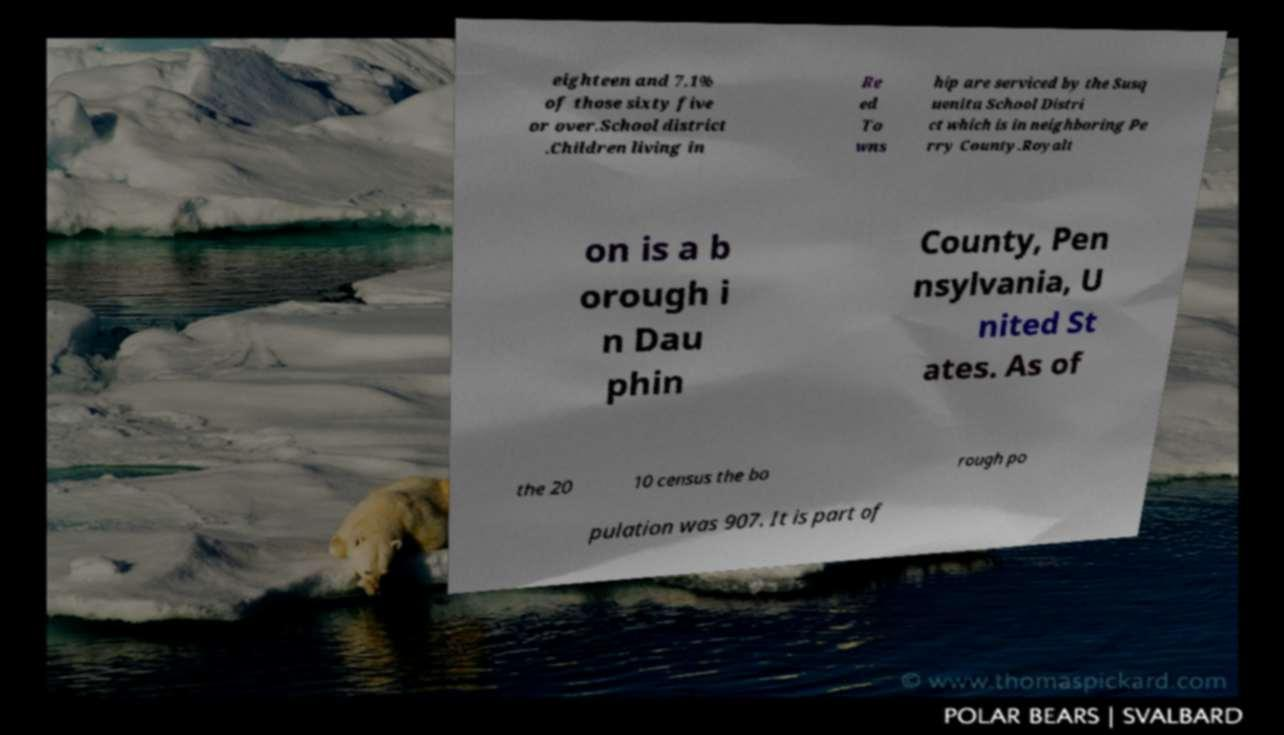For documentation purposes, I need the text within this image transcribed. Could you provide that? eighteen and 7.1% of those sixty five or over.School district .Children living in Re ed To wns hip are serviced by the Susq uenita School Distri ct which is in neighboring Pe rry County.Royalt on is a b orough i n Dau phin County, Pen nsylvania, U nited St ates. As of the 20 10 census the bo rough po pulation was 907. It is part of 